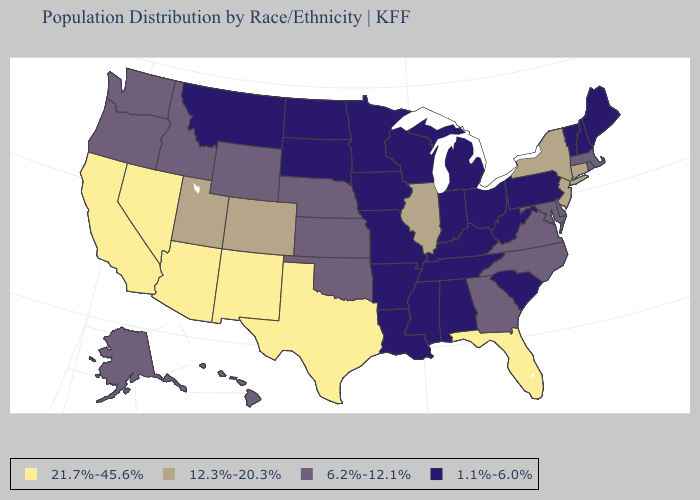Name the states that have a value in the range 1.1%-6.0%?
Answer briefly. Alabama, Arkansas, Indiana, Iowa, Kentucky, Louisiana, Maine, Michigan, Minnesota, Mississippi, Missouri, Montana, New Hampshire, North Dakota, Ohio, Pennsylvania, South Carolina, South Dakota, Tennessee, Vermont, West Virginia, Wisconsin. Among the states that border Arizona , which have the lowest value?
Short answer required. Colorado, Utah. Does Illinois have the highest value in the MidWest?
Write a very short answer. Yes. What is the highest value in states that border Kansas?
Answer briefly. 12.3%-20.3%. Does Rhode Island have a lower value than New York?
Concise answer only. Yes. Which states hav the highest value in the Northeast?
Keep it brief. Connecticut, New Jersey, New York. What is the value of California?
Short answer required. 21.7%-45.6%. What is the highest value in the South ?
Be succinct. 21.7%-45.6%. Does the first symbol in the legend represent the smallest category?
Write a very short answer. No. What is the value of Arkansas?
Be succinct. 1.1%-6.0%. Among the states that border South Carolina , which have the highest value?
Write a very short answer. Georgia, North Carolina. Does Utah have the same value as Alabama?
Answer briefly. No. What is the value of Delaware?
Keep it brief. 6.2%-12.1%. Name the states that have a value in the range 12.3%-20.3%?
Be succinct. Colorado, Connecticut, Illinois, New Jersey, New York, Utah. Name the states that have a value in the range 21.7%-45.6%?
Answer briefly. Arizona, California, Florida, Nevada, New Mexico, Texas. 